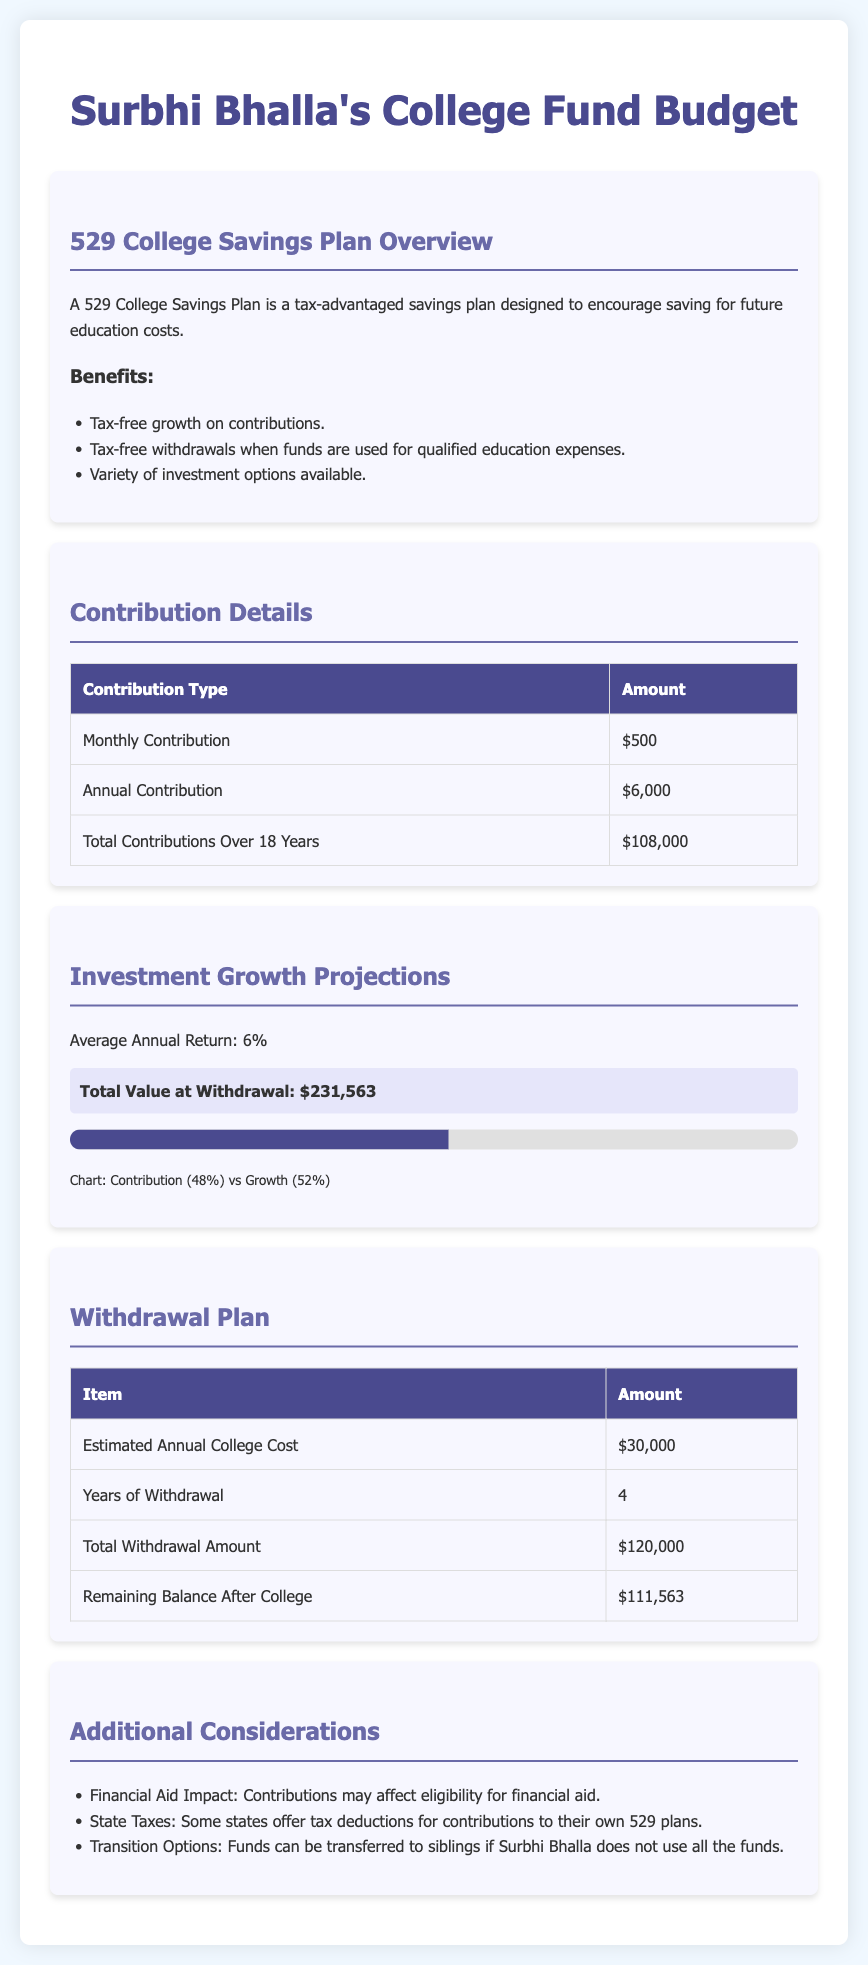What is the monthly contribution amount? The monthly contribution amount is specifically stated in the Contribution Details section.
Answer: $500 What is the total contribution over 18 years? The total contributions over 18 years are listed in the Contribution Details section.
Answer: $108,000 What is the average annual return? The average annual return is mentioned in the Investment Growth Projections section of the document.
Answer: 6% What is the total value at withdrawal? The total value at withdrawal is highlighted in the Investment Growth Projections section.
Answer: $231,563 What is the estimated annual college cost? The estimated annual college cost is specified in the Withdrawal Plan section.
Answer: $30,000 How many years of withdrawal are planned? The years of withdrawal are detailed in the Withdrawal Plan section of the document.
Answer: 4 What is the remaining balance after college? The remaining balance after college is shown in the Withdrawal Plan table.
Answer: $111,563 What are two benefits of the 529 College Savings Plan? The benefits are listed in the 529 College Savings Plan Overview.
Answer: Tax-free growth, Tax-free withdrawals What can happen to the funds if Surbhi Bhalla does not use all of them? This information is provided in the Additional Considerations section, addressing the funds' future use.
Answer: Funds can be transferred to siblings 